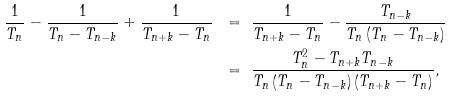<formula> <loc_0><loc_0><loc_500><loc_500>\frac { 1 } { T _ { n } } - \frac { 1 } { T _ { n } - T _ { n - k } } + \frac { 1 } { T _ { n + k } - T _ { n } } \ & = \ \frac { 1 } { T _ { n + k } - T _ { n } } - \frac { T _ { n - k } } { T _ { n } \left ( T _ { n } - T _ { n - k } \right ) } \\ \ & = \ \frac { T _ { n } ^ { 2 } - T _ { n + k } T _ { n - k } } { T _ { n } \left ( T _ { n } - T _ { n - k } \right ) \left ( T _ { n + k } - T _ { n } \right ) } ,</formula> 